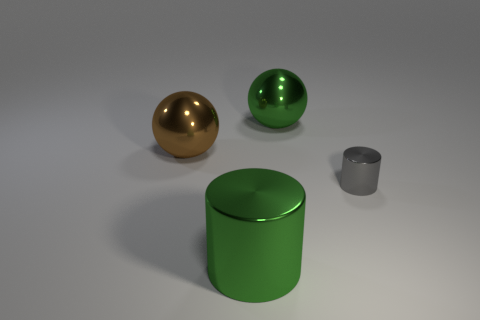Add 4 tiny red matte things. How many objects exist? 8 Add 4 metal cylinders. How many metal cylinders are left? 6 Add 1 large green cylinders. How many large green cylinders exist? 2 Subtract 0 red blocks. How many objects are left? 4 Subtract all red rubber cylinders. Subtract all large metallic cylinders. How many objects are left? 3 